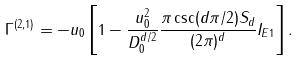Convert formula to latex. <formula><loc_0><loc_0><loc_500><loc_500>\Gamma ^ { ( 2 , 1 ) } = - u _ { 0 } \left [ 1 - \frac { u _ { 0 } ^ { 2 } } { D _ { 0 } ^ { d / 2 } } \frac { \pi \csc ( d \pi / 2 ) S _ { d } } { ( 2 \pi ) ^ { d } } I _ { E 1 } \right ] .</formula> 